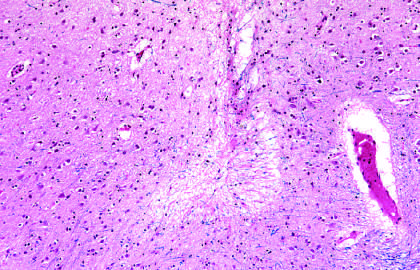what are seen as areas of tissue loss and residual gliosis?
Answer the question using a single word or phrase. Old intracortical infarcts 